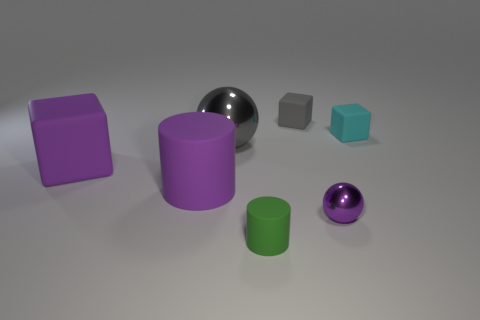There is a big matte object that is on the right side of the big purple matte cube; is its color the same as the shiny sphere that is on the right side of the green object?
Provide a succinct answer. Yes. Are any small blue metallic cubes visible?
Offer a terse response. No. There is a tiny object that is the same color as the big block; what material is it?
Keep it short and to the point. Metal. There is a cylinder that is in front of the purple thing to the right of the sphere to the left of the small gray cube; how big is it?
Offer a very short reply. Small. There is a tiny gray thing; does it have the same shape as the tiny rubber thing that is on the right side of the small purple thing?
Keep it short and to the point. Yes. Are there any large cylinders of the same color as the small ball?
Ensure brevity in your answer.  Yes. How many balls are either big gray objects or small gray things?
Make the answer very short. 1. Is there a purple rubber object that has the same shape as the big shiny object?
Ensure brevity in your answer.  No. What number of other objects are there of the same color as the small rubber cylinder?
Your answer should be very brief. 0. Are there fewer tiny gray things that are in front of the gray metal object than big cyan rubber cylinders?
Your response must be concise. No. 